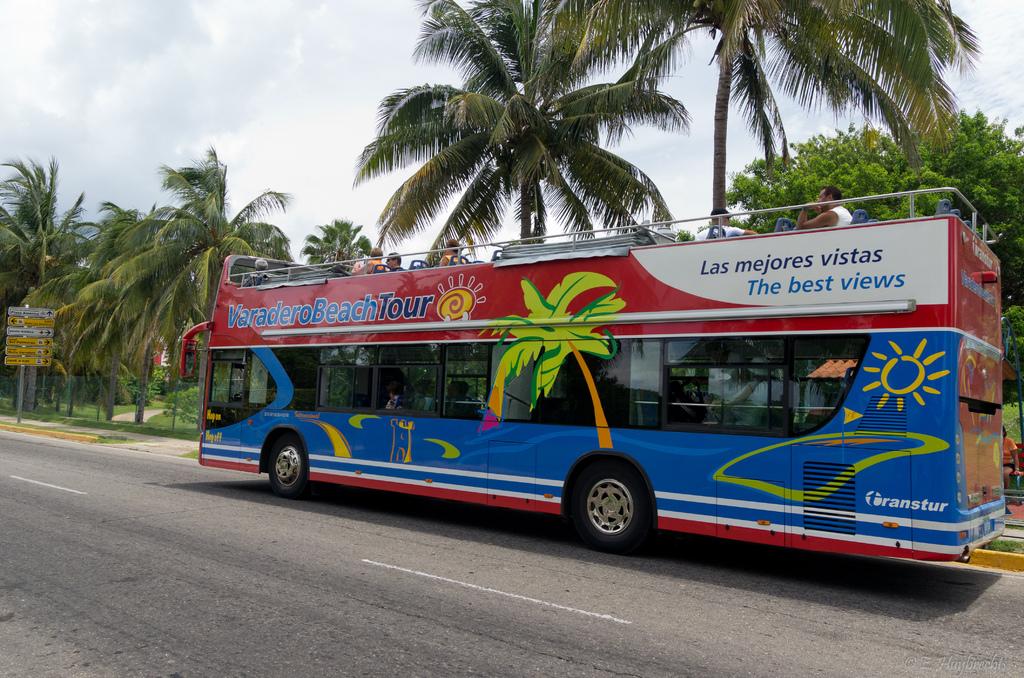What does it say in english under 'las mejores vistas'?
Your answer should be compact. The best views. Is this a beach tour bus?
Keep it short and to the point. Yes. 